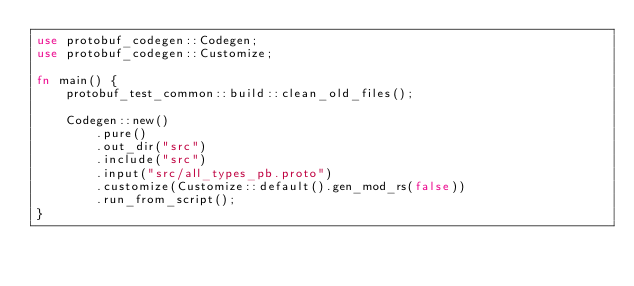<code> <loc_0><loc_0><loc_500><loc_500><_Rust_>use protobuf_codegen::Codegen;
use protobuf_codegen::Customize;

fn main() {
    protobuf_test_common::build::clean_old_files();

    Codegen::new()
        .pure()
        .out_dir("src")
        .include("src")
        .input("src/all_types_pb.proto")
        .customize(Customize::default().gen_mod_rs(false))
        .run_from_script();
}
</code> 